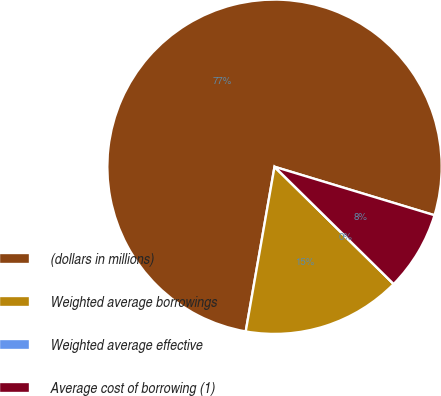Convert chart. <chart><loc_0><loc_0><loc_500><loc_500><pie_chart><fcel>(dollars in millions)<fcel>Weighted average borrowings<fcel>Weighted average effective<fcel>Average cost of borrowing (1)<nl><fcel>76.92%<fcel>15.38%<fcel>0.0%<fcel>7.69%<nl></chart> 